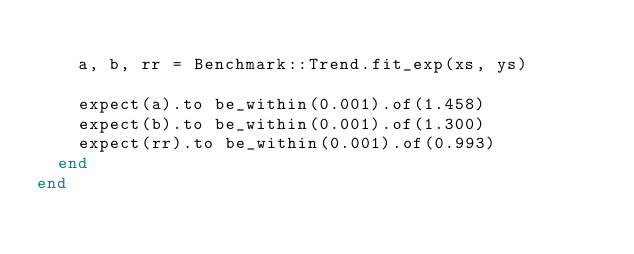Convert code to text. <code><loc_0><loc_0><loc_500><loc_500><_Ruby_>
    a, b, rr = Benchmark::Trend.fit_exp(xs, ys)

    expect(a).to be_within(0.001).of(1.458)
    expect(b).to be_within(0.001).of(1.300)
    expect(rr).to be_within(0.001).of(0.993)
  end
end
</code> 